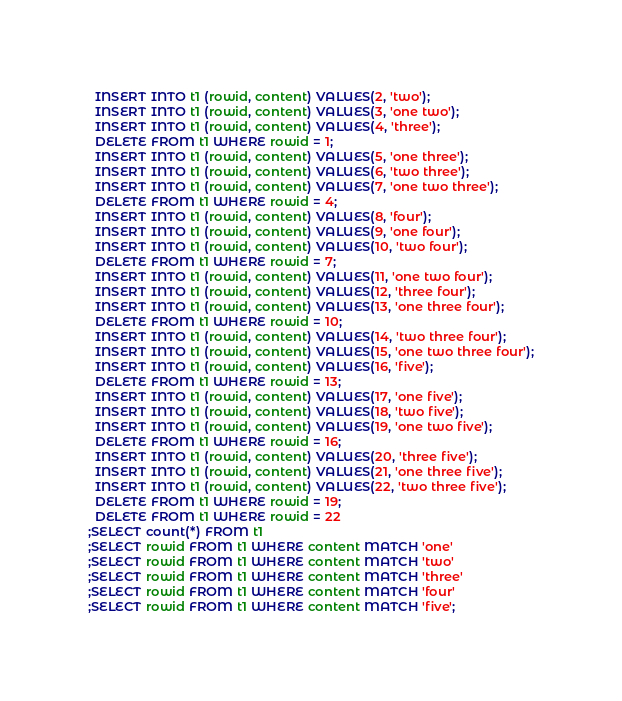<code> <loc_0><loc_0><loc_500><loc_500><_SQL_>  INSERT INTO t1 (rowid, content) VALUES(2, 'two');
  INSERT INTO t1 (rowid, content) VALUES(3, 'one two');
  INSERT INTO t1 (rowid, content) VALUES(4, 'three');
  DELETE FROM t1 WHERE rowid = 1;
  INSERT INTO t1 (rowid, content) VALUES(5, 'one three');
  INSERT INTO t1 (rowid, content) VALUES(6, 'two three');
  INSERT INTO t1 (rowid, content) VALUES(7, 'one two three');
  DELETE FROM t1 WHERE rowid = 4;
  INSERT INTO t1 (rowid, content) VALUES(8, 'four');
  INSERT INTO t1 (rowid, content) VALUES(9, 'one four');
  INSERT INTO t1 (rowid, content) VALUES(10, 'two four');
  DELETE FROM t1 WHERE rowid = 7;
  INSERT INTO t1 (rowid, content) VALUES(11, 'one two four');
  INSERT INTO t1 (rowid, content) VALUES(12, 'three four');
  INSERT INTO t1 (rowid, content) VALUES(13, 'one three four');
  DELETE FROM t1 WHERE rowid = 10;
  INSERT INTO t1 (rowid, content) VALUES(14, 'two three four');
  INSERT INTO t1 (rowid, content) VALUES(15, 'one two three four');
  INSERT INTO t1 (rowid, content) VALUES(16, 'five');
  DELETE FROM t1 WHERE rowid = 13;
  INSERT INTO t1 (rowid, content) VALUES(17, 'one five');
  INSERT INTO t1 (rowid, content) VALUES(18, 'two five');
  INSERT INTO t1 (rowid, content) VALUES(19, 'one two five');
  DELETE FROM t1 WHERE rowid = 16;
  INSERT INTO t1 (rowid, content) VALUES(20, 'three five');
  INSERT INTO t1 (rowid, content) VALUES(21, 'one three five');
  INSERT INTO t1 (rowid, content) VALUES(22, 'two three five');
  DELETE FROM t1 WHERE rowid = 19;
  DELETE FROM t1 WHERE rowid = 22
;SELECT count(*) FROM t1
;SELECT rowid FROM t1 WHERE content MATCH 'one'
;SELECT rowid FROM t1 WHERE content MATCH 'two'
;SELECT rowid FROM t1 WHERE content MATCH 'three'
;SELECT rowid FROM t1 WHERE content MATCH 'four'
;SELECT rowid FROM t1 WHERE content MATCH 'five';</code> 